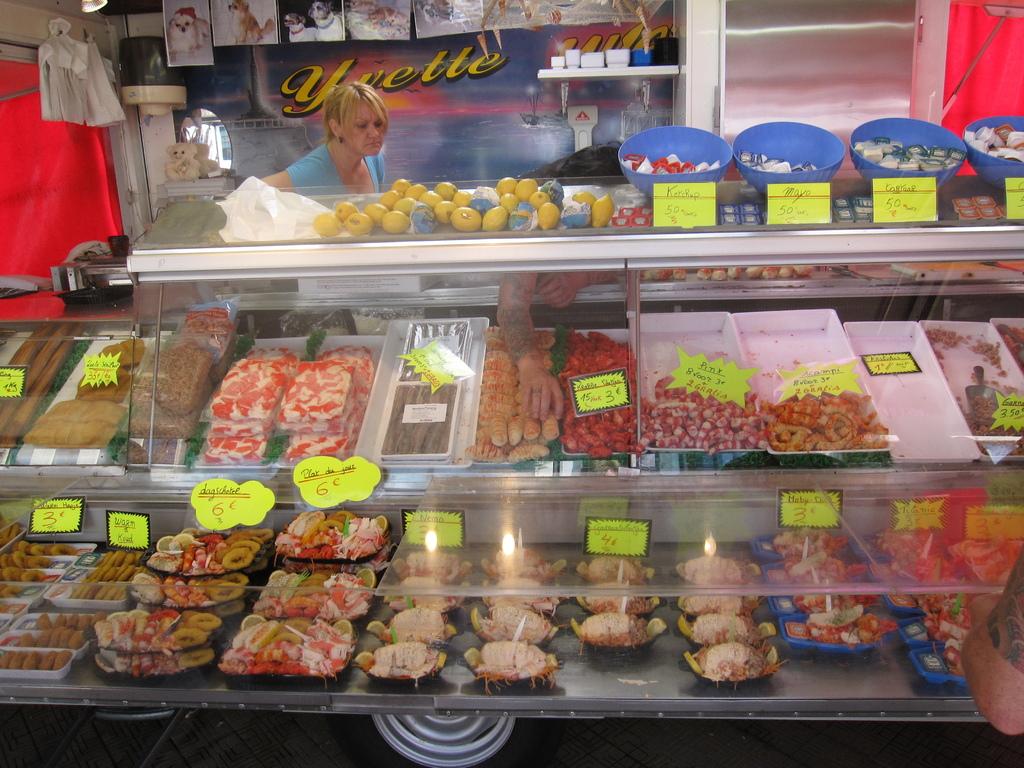What is the name of this store?
Your response must be concise. Yvette. What number is in the bottom left hand corner item?
Offer a very short reply. 3. 